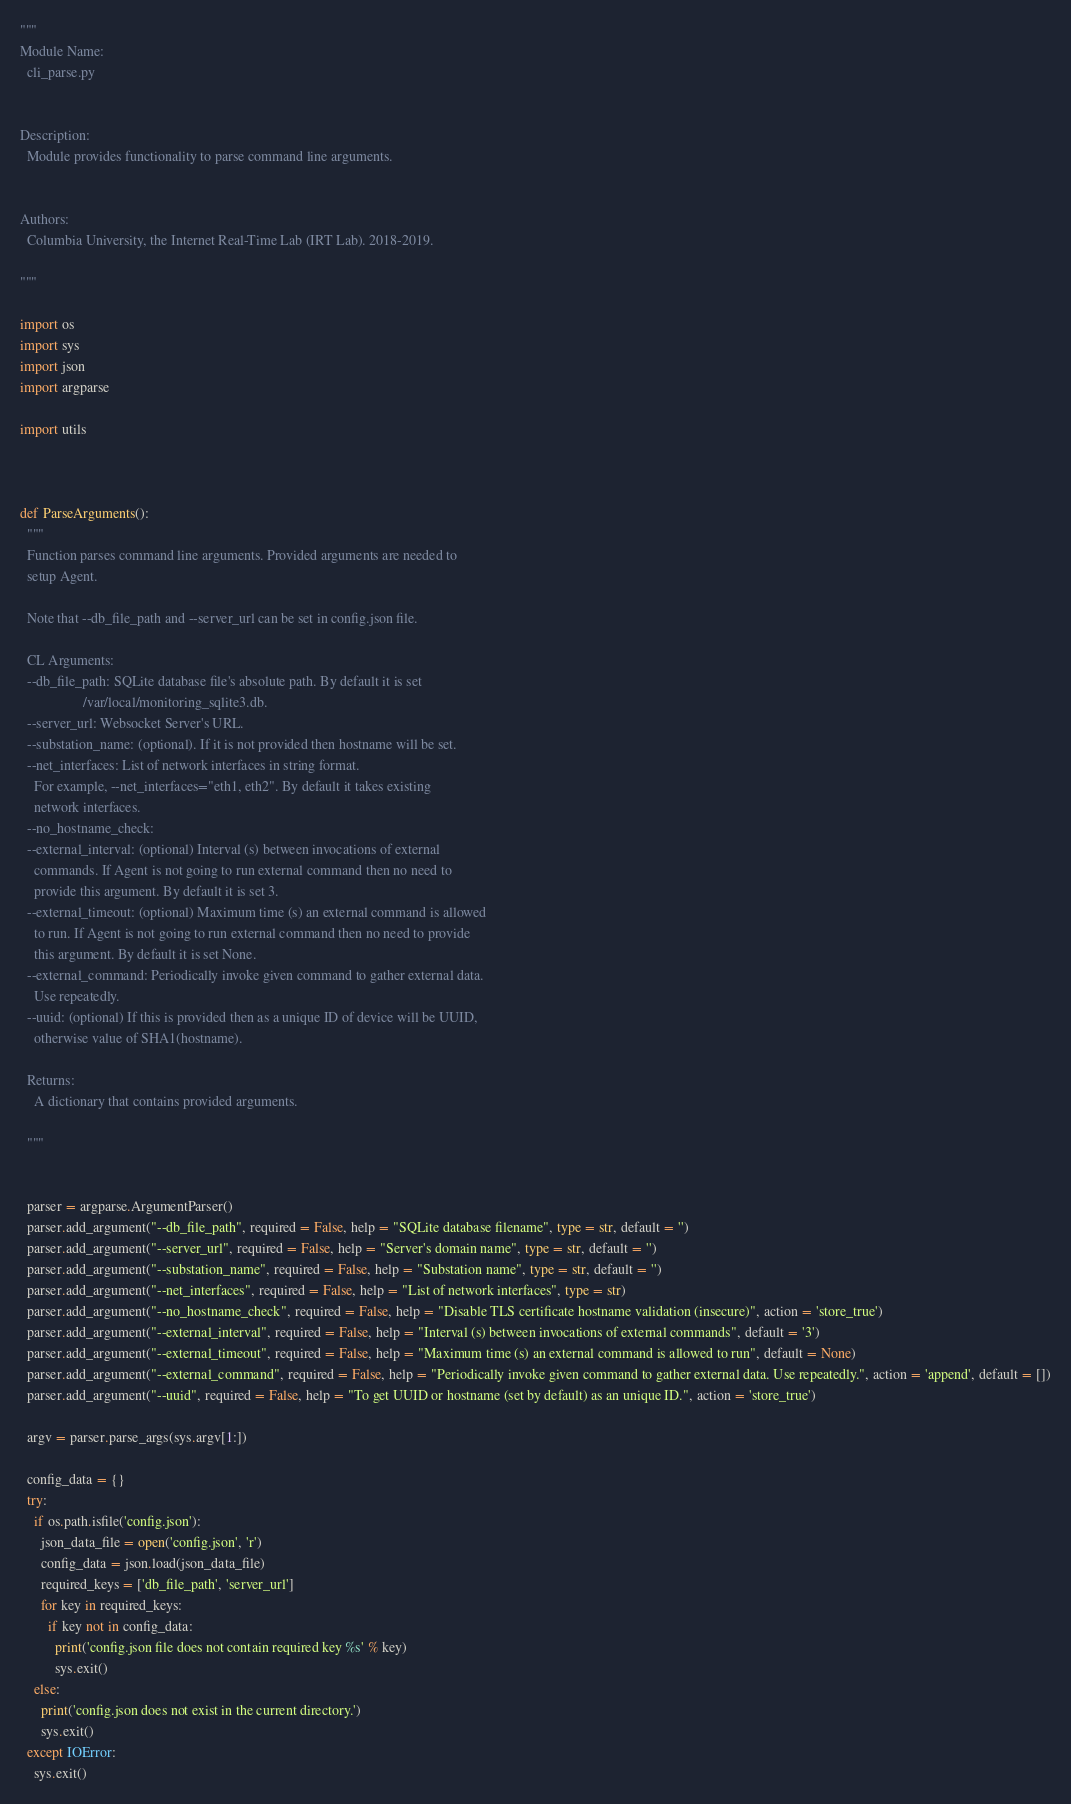Convert code to text. <code><loc_0><loc_0><loc_500><loc_500><_Python_>"""
Module Name:
  cli_parse.py


Description:
  Module provides functionality to parse command line arguments.


Authors:
  Columbia University, the Internet Real-Time Lab (IRT Lab). 2018-2019.

"""

import os
import sys
import json
import argparse

import utils



def ParseArguments():
  """
  Function parses command line arguments. Provided arguments are needed to
  setup Agent.

  Note that --db_file_path and --server_url can be set in config.json file.

  CL Arguments:
  --db_file_path: SQLite database file's absolute path. By default it is set
                  /var/local/monitoring_sqlite3.db.
  --server_url: Websocket Server's URL.
  --substation_name: (optional). If it is not provided then hostname will be set.
  --net_interfaces: List of network interfaces in string format.
    For example, --net_interfaces="eth1, eth2". By default it takes existing
    network interfaces.
  --no_hostname_check:
  --external_interval: (optional) Interval (s) between invocations of external
    commands. If Agent is not going to run external command then no need to
    provide this argument. By default it is set 3.
  --external_timeout: (optional) Maximum time (s) an external command is allowed
    to run. If Agent is not going to run external command then no need to provide
    this argument. By default it is set None.
  --external_command: Periodically invoke given command to gather external data.
    Use repeatedly.
  --uuid: (optional) If this is provided then as a unique ID of device will be UUID,
    otherwise value of SHA1(hostname).

  Returns:
    A dictionary that contains provided arguments.

  """


  parser = argparse.ArgumentParser()
  parser.add_argument("--db_file_path", required = False, help = "SQLite database filename", type = str, default = '')
  parser.add_argument("--server_url", required = False, help = "Server's domain name", type = str, default = '')
  parser.add_argument("--substation_name", required = False, help = "Substation name", type = str, default = '')
  parser.add_argument("--net_interfaces", required = False, help = "List of network interfaces", type = str)
  parser.add_argument("--no_hostname_check", required = False, help = "Disable TLS certificate hostname validation (insecure)", action = 'store_true')
  parser.add_argument("--external_interval", required = False, help = "Interval (s) between invocations of external commands", default = '3')
  parser.add_argument("--external_timeout", required = False, help = "Maximum time (s) an external command is allowed to run", default = None)
  parser.add_argument("--external_command", required = False, help = "Periodically invoke given command to gather external data. Use repeatedly.", action = 'append', default = [])
  parser.add_argument("--uuid", required = False, help = "To get UUID or hostname (set by default) as an unique ID.", action = 'store_true')

  argv = parser.parse_args(sys.argv[1:])

  config_data = {}
  try:
    if os.path.isfile('config.json'):
      json_data_file = open('config.json', 'r')
      config_data = json.load(json_data_file)
      required_keys = ['db_file_path', 'server_url']
      for key in required_keys:
        if key not in config_data:
          print('config.json file does not contain required key %s' % key)
          sys.exit()
    else:
      print('config.json does not exist in the current directory.')
      sys.exit()
  except IOError:
    sys.exit()
</code> 